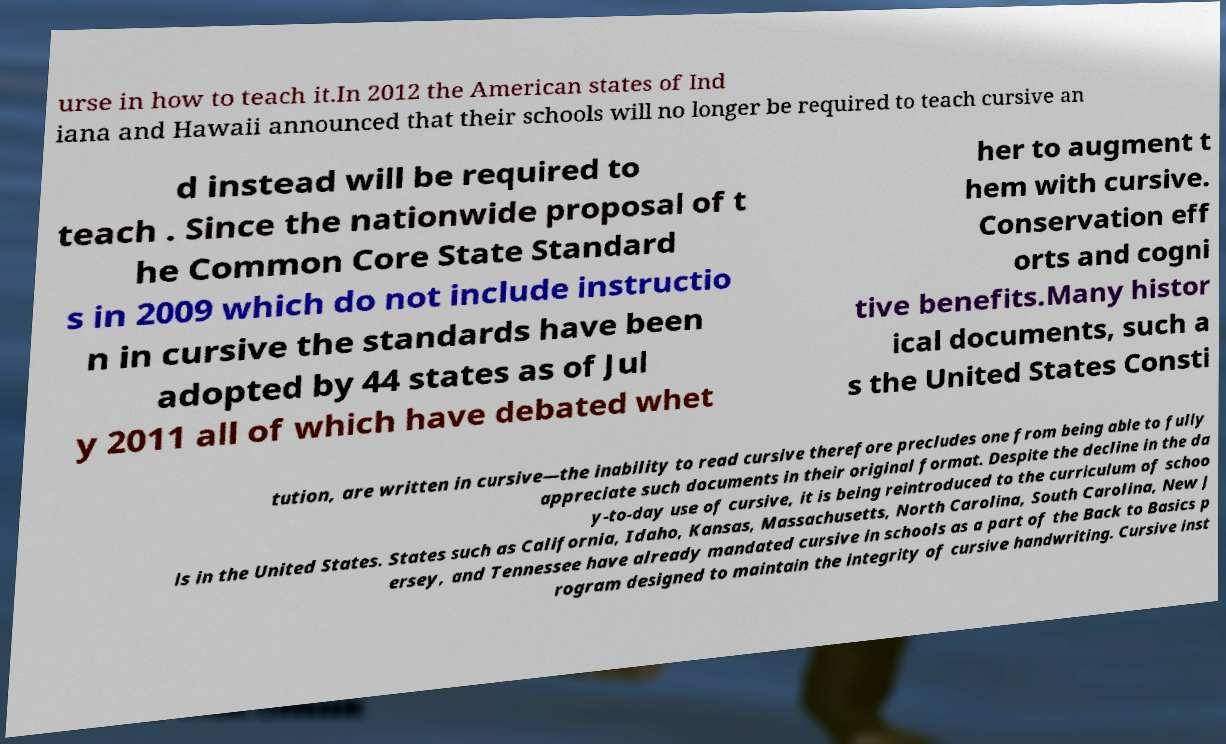Please read and relay the text visible in this image. What does it say? urse in how to teach it.In 2012 the American states of Ind iana and Hawaii announced that their schools will no longer be required to teach cursive an d instead will be required to teach . Since the nationwide proposal of t he Common Core State Standard s in 2009 which do not include instructio n in cursive the standards have been adopted by 44 states as of Jul y 2011 all of which have debated whet her to augment t hem with cursive. Conservation eff orts and cogni tive benefits.Many histor ical documents, such a s the United States Consti tution, are written in cursive—the inability to read cursive therefore precludes one from being able to fully appreciate such documents in their original format. Despite the decline in the da y-to-day use of cursive, it is being reintroduced to the curriculum of schoo ls in the United States. States such as California, Idaho, Kansas, Massachusetts, North Carolina, South Carolina, New J ersey, and Tennessee have already mandated cursive in schools as a part of the Back to Basics p rogram designed to maintain the integrity of cursive handwriting. Cursive inst 